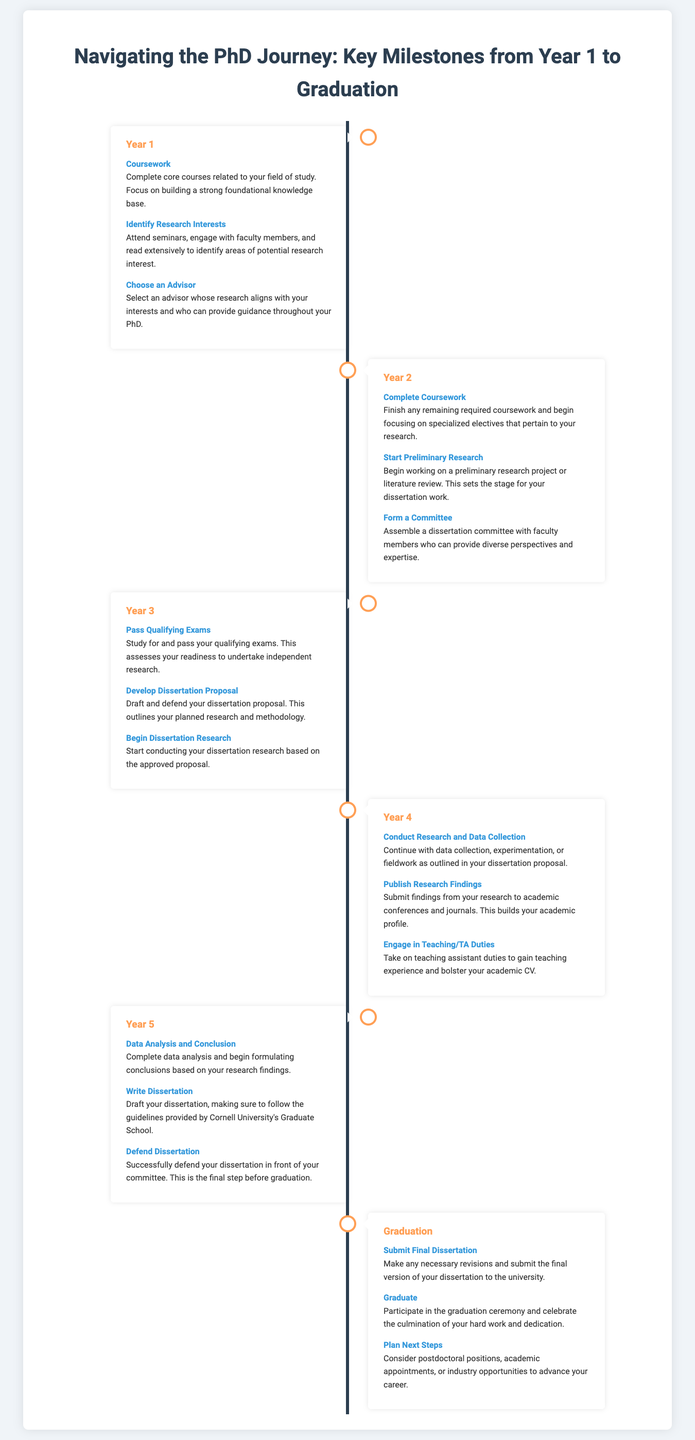What are the key milestones in Year 1? The milestones listed for Year 1 include "Coursework," "Identify Research Interests," and "Choose an Advisor."
Answer: Coursework, Identify Research Interests, Choose an Advisor What is the major task in Year 3? In Year 3, the major tasks include "Pass Qualifying Exams," "Develop Dissertation Proposal," and "Begin Dissertation Research."
Answer: Pass Qualifying Exams, Develop Dissertation Proposal, Begin Dissertation Research How many milestones are listed for Year 5? There are three milestones specified for Year 5, which are "Data Analysis and Conclusion," "Write Dissertation," and "Defend Dissertation."
Answer: 3 What does the final milestone for Graduation entail? The final milestone for Graduation is "Plan Next Steps," which involves considering future career opportunities after graduation.
Answer: Plan Next Steps Which year involves forming a committee? Forming a committee is a task in Year 2 as noted in the milestones.
Answer: Year 2 What key activity is indicated for Year 4? The key activities indicated for Year 4 include "Conduct Research and Data Collection" and "Publish Research Findings."
Answer: Conduct Research and Data Collection, Publish Research Findings In which year do students typically write their dissertation? Writing the dissertation is typically done in Year 5 as outlined in the milestones.
Answer: Year 5 What is the color of the timeline? The color of the timeline is specified as "#2c3e50."
Answer: #2c3e50 